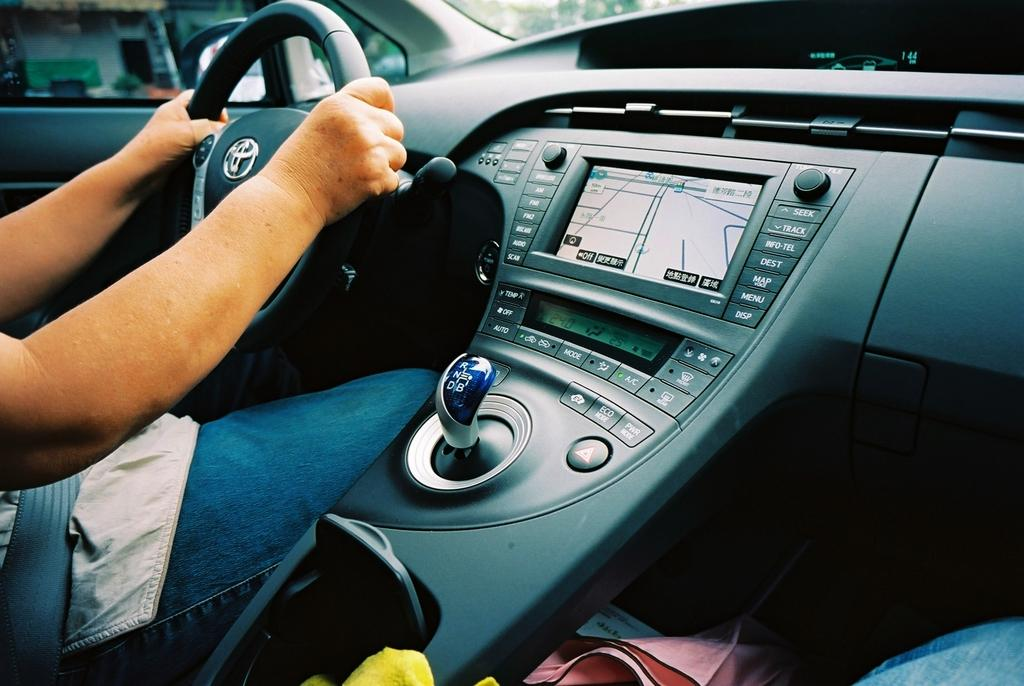What is the person in the image holding? The person's hands are holding a steering wheel in the image. What type of object does the steering wheel belong to? The steering wheel belongs to a vehicle. What can be seen in the background of the image? There is a shed and trees in the background of the image. Where is the throne located in the image? There is no throne present in the image. How many apples are on the trees in the image? There is no mention of apples or trees with apples in the image. 